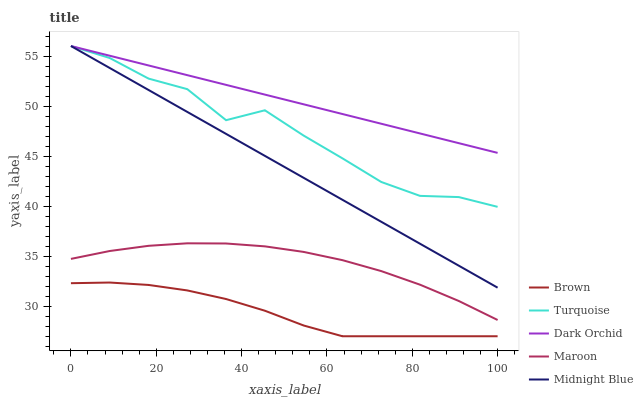Does Brown have the minimum area under the curve?
Answer yes or no. Yes. Does Dark Orchid have the maximum area under the curve?
Answer yes or no. Yes. Does Turquoise have the minimum area under the curve?
Answer yes or no. No. Does Turquoise have the maximum area under the curve?
Answer yes or no. No. Is Midnight Blue the smoothest?
Answer yes or no. Yes. Is Turquoise the roughest?
Answer yes or no. Yes. Is Maroon the smoothest?
Answer yes or no. No. Is Maroon the roughest?
Answer yes or no. No. Does Brown have the lowest value?
Answer yes or no. Yes. Does Turquoise have the lowest value?
Answer yes or no. No. Does Midnight Blue have the highest value?
Answer yes or no. Yes. Does Maroon have the highest value?
Answer yes or no. No. Is Brown less than Turquoise?
Answer yes or no. Yes. Is Dark Orchid greater than Maroon?
Answer yes or no. Yes. Does Turquoise intersect Midnight Blue?
Answer yes or no. Yes. Is Turquoise less than Midnight Blue?
Answer yes or no. No. Is Turquoise greater than Midnight Blue?
Answer yes or no. No. Does Brown intersect Turquoise?
Answer yes or no. No. 